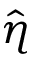<formula> <loc_0><loc_0><loc_500><loc_500>\hat { \eta }</formula> 